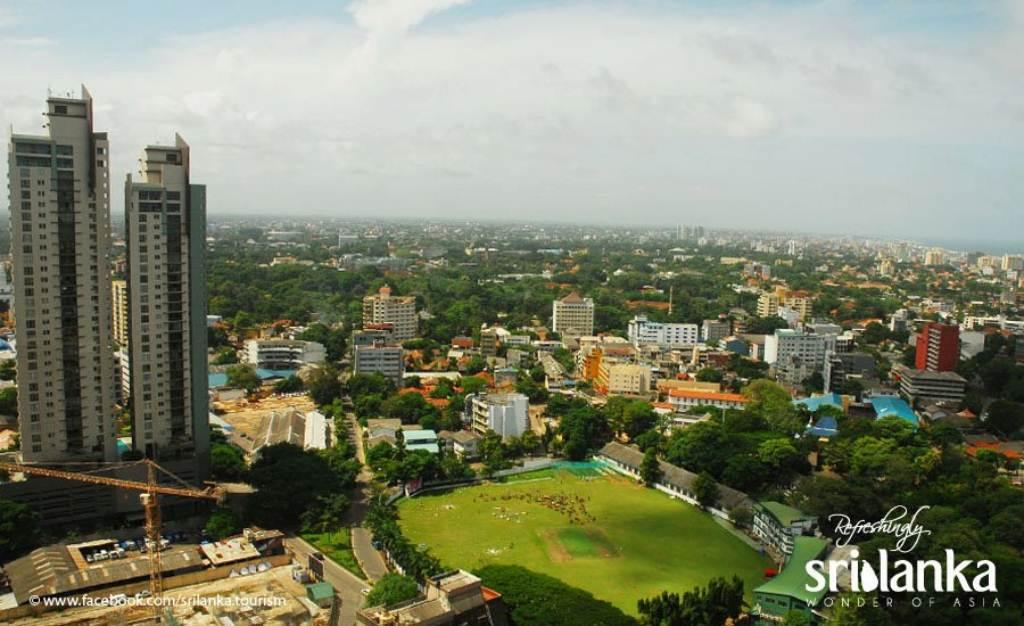What type of structures are present in the image? There is a group of buildings in the image. What other natural elements can be seen in the image? There are trees in the image. What is visible at the top of the image? The sky is visible at the top of the image. Where is the text located in the image? The text is in the bottom right corner of the image. What type of rock can be seen in the image? There is no rock present in the image. Is there a battle taking place in the image? There is no battle depicted in the image. 